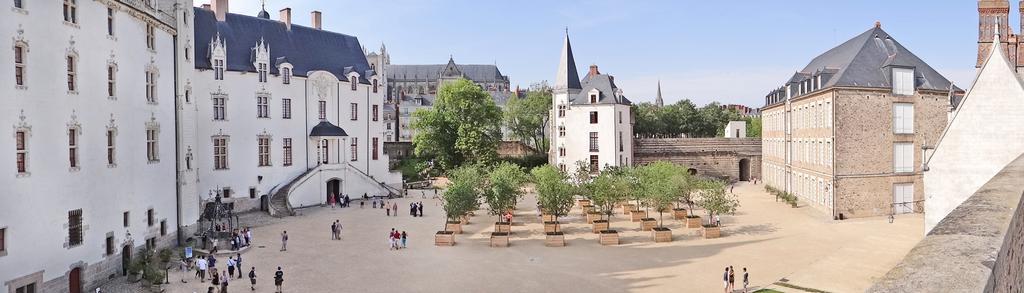Can you describe this image briefly? In this image there are buildings, trees, plants, well, boards, people, lights, sky, steps and objects. 